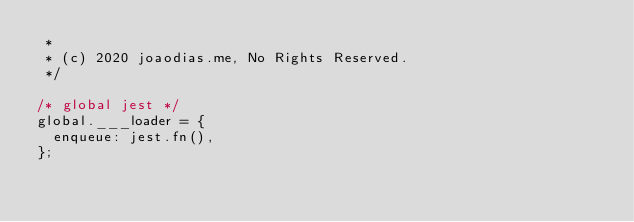<code> <loc_0><loc_0><loc_500><loc_500><_JavaScript_> *
 * (c) 2020 joaodias.me, No Rights Reserved.
 */

/* global jest */
global.___loader = {
	enqueue: jest.fn(),
};
</code> 